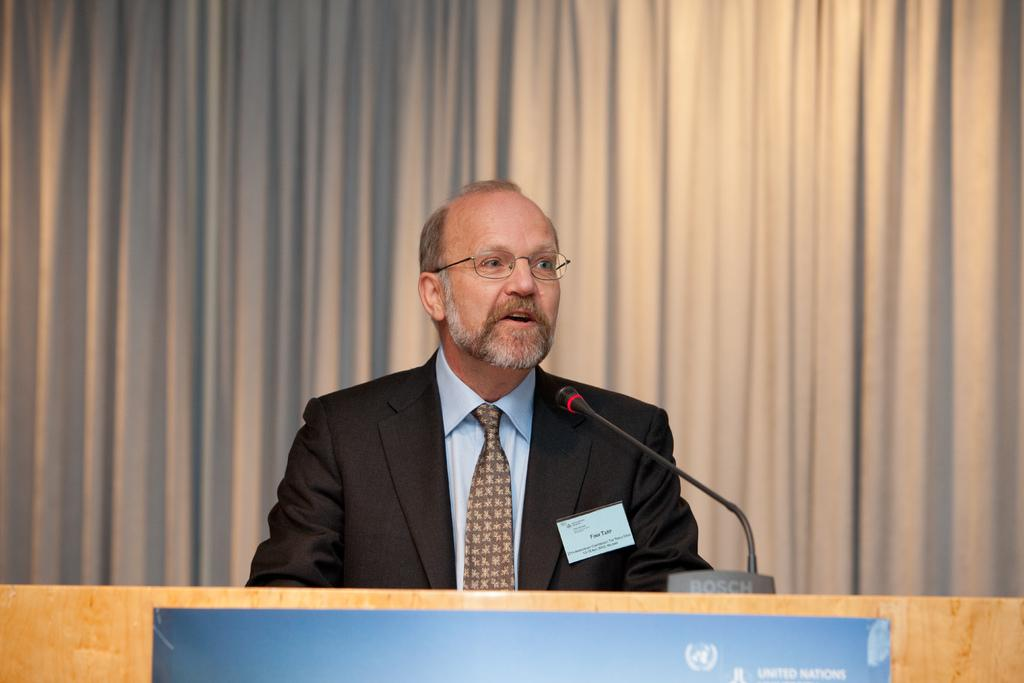Who is in the image? There is a man in the image. What is the man doing in the image? The man is sitting. What object is on the table in the image? A microphone is present on the table. What type of covering is visible in the image? There is a curtain visible in the image. How many cows are visible behind the curtain in the image? There are no cows visible behind the curtain in the image. What color is the egg that the man is holding in the image? The man is not holding an egg in the image. 